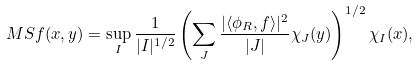Convert formula to latex. <formula><loc_0><loc_0><loc_500><loc_500>M S f ( x , y ) = \sup _ { I } \frac { 1 } { | I | ^ { 1 / 2 } } \left ( \sum _ { J } \frac { | \langle \phi _ { R } , f \rangle | ^ { 2 } } { | J | } \chi _ { J } ( y ) \right ) ^ { 1 / 2 } \chi _ { I } ( x ) ,</formula> 